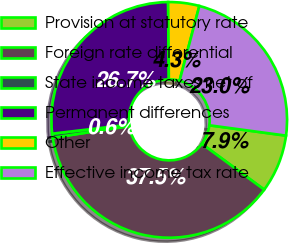Convert chart to OTSL. <chart><loc_0><loc_0><loc_500><loc_500><pie_chart><fcel>Provision at statutory rate<fcel>Foreign rate differential<fcel>State income taxes net of<fcel>Permanent differences<fcel>Other<fcel>Effective income tax rate<nl><fcel>7.95%<fcel>37.49%<fcel>0.56%<fcel>26.72%<fcel>4.26%<fcel>23.02%<nl></chart> 